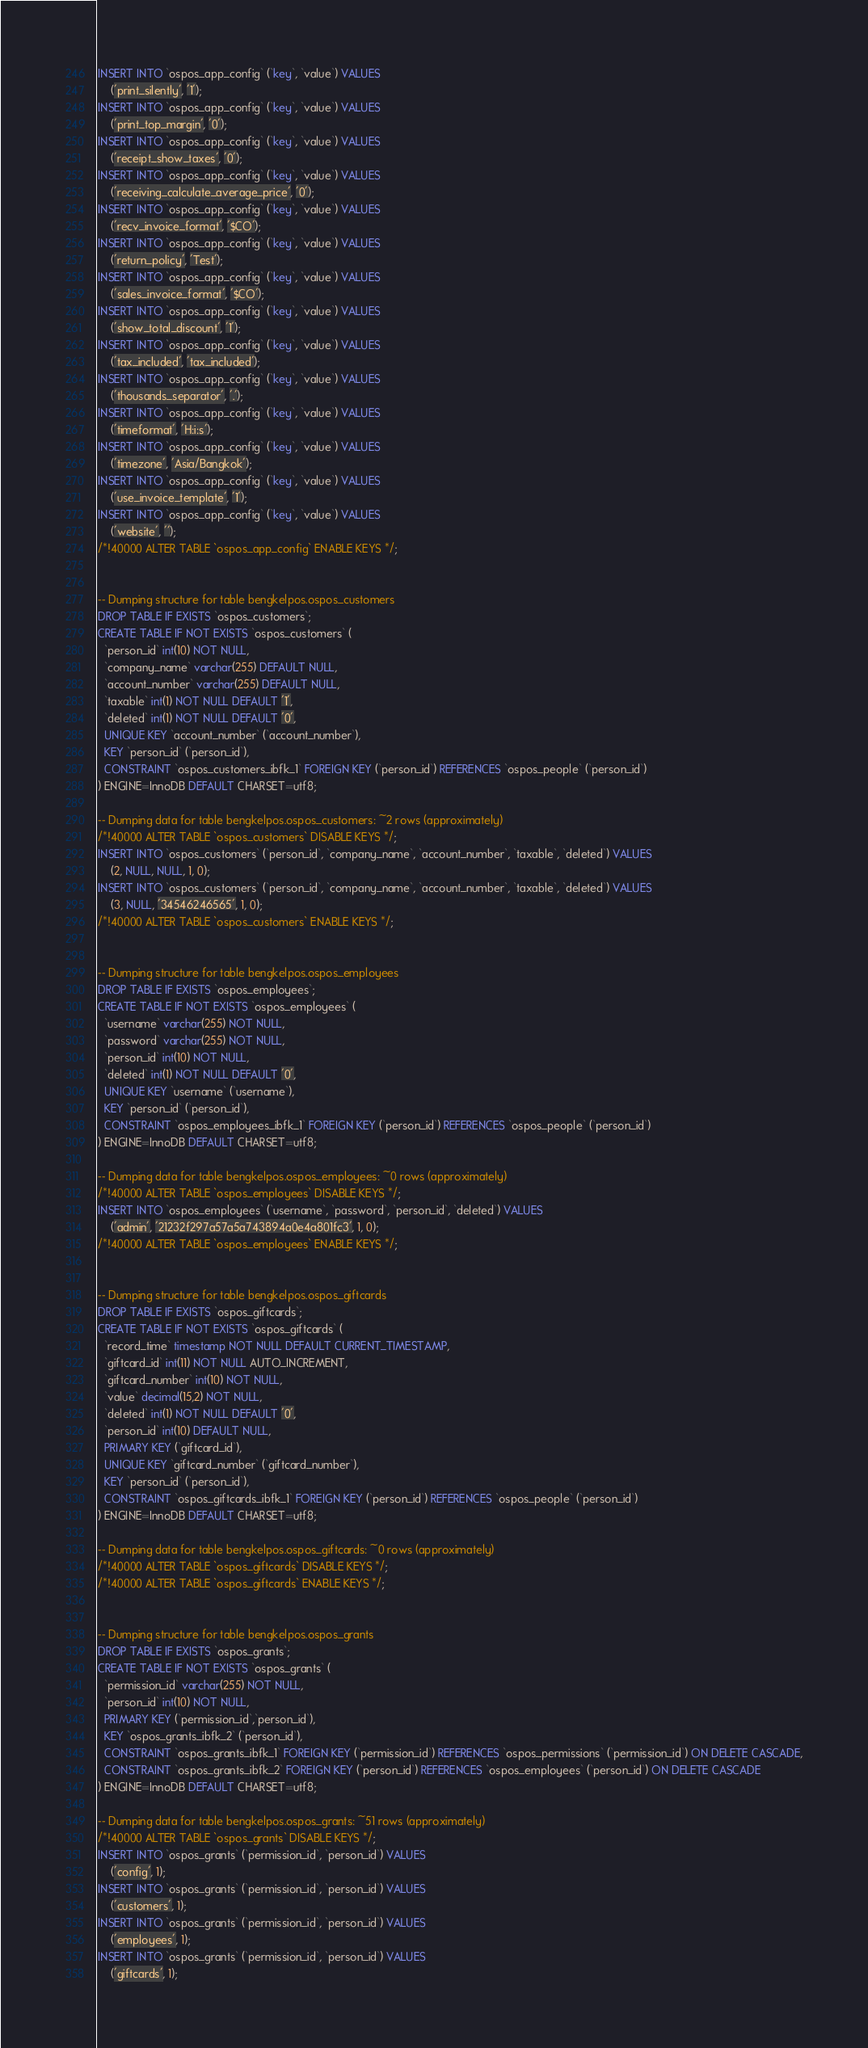Convert code to text. <code><loc_0><loc_0><loc_500><loc_500><_SQL_>INSERT INTO `ospos_app_config` (`key`, `value`) VALUES
	('print_silently', '1');
INSERT INTO `ospos_app_config` (`key`, `value`) VALUES
	('print_top_margin', '0');
INSERT INTO `ospos_app_config` (`key`, `value`) VALUES
	('receipt_show_taxes', '0');
INSERT INTO `ospos_app_config` (`key`, `value`) VALUES
	('receiving_calculate_average_price', '0');
INSERT INTO `ospos_app_config` (`key`, `value`) VALUES
	('recv_invoice_format', '$CO');
INSERT INTO `ospos_app_config` (`key`, `value`) VALUES
	('return_policy', 'Test');
INSERT INTO `ospos_app_config` (`key`, `value`) VALUES
	('sales_invoice_format', '$CO');
INSERT INTO `ospos_app_config` (`key`, `value`) VALUES
	('show_total_discount', '1');
INSERT INTO `ospos_app_config` (`key`, `value`) VALUES
	('tax_included', 'tax_included');
INSERT INTO `ospos_app_config` (`key`, `value`) VALUES
	('thousands_separator', '.');
INSERT INTO `ospos_app_config` (`key`, `value`) VALUES
	('timeformat', 'H:i:s');
INSERT INTO `ospos_app_config` (`key`, `value`) VALUES
	('timezone', 'Asia/Bangkok');
INSERT INTO `ospos_app_config` (`key`, `value`) VALUES
	('use_invoice_template', '1');
INSERT INTO `ospos_app_config` (`key`, `value`) VALUES
	('website', '');
/*!40000 ALTER TABLE `ospos_app_config` ENABLE KEYS */;


-- Dumping structure for table bengkelpos.ospos_customers
DROP TABLE IF EXISTS `ospos_customers`;
CREATE TABLE IF NOT EXISTS `ospos_customers` (
  `person_id` int(10) NOT NULL,
  `company_name` varchar(255) DEFAULT NULL,
  `account_number` varchar(255) DEFAULT NULL,
  `taxable` int(1) NOT NULL DEFAULT '1',
  `deleted` int(1) NOT NULL DEFAULT '0',
  UNIQUE KEY `account_number` (`account_number`),
  KEY `person_id` (`person_id`),
  CONSTRAINT `ospos_customers_ibfk_1` FOREIGN KEY (`person_id`) REFERENCES `ospos_people` (`person_id`)
) ENGINE=InnoDB DEFAULT CHARSET=utf8;

-- Dumping data for table bengkelpos.ospos_customers: ~2 rows (approximately)
/*!40000 ALTER TABLE `ospos_customers` DISABLE KEYS */;
INSERT INTO `ospos_customers` (`person_id`, `company_name`, `account_number`, `taxable`, `deleted`) VALUES
	(2, NULL, NULL, 1, 0);
INSERT INTO `ospos_customers` (`person_id`, `company_name`, `account_number`, `taxable`, `deleted`) VALUES
	(3, NULL, '34546246565', 1, 0);
/*!40000 ALTER TABLE `ospos_customers` ENABLE KEYS */;


-- Dumping structure for table bengkelpos.ospos_employees
DROP TABLE IF EXISTS `ospos_employees`;
CREATE TABLE IF NOT EXISTS `ospos_employees` (
  `username` varchar(255) NOT NULL,
  `password` varchar(255) NOT NULL,
  `person_id` int(10) NOT NULL,
  `deleted` int(1) NOT NULL DEFAULT '0',
  UNIQUE KEY `username` (`username`),
  KEY `person_id` (`person_id`),
  CONSTRAINT `ospos_employees_ibfk_1` FOREIGN KEY (`person_id`) REFERENCES `ospos_people` (`person_id`)
) ENGINE=InnoDB DEFAULT CHARSET=utf8;

-- Dumping data for table bengkelpos.ospos_employees: ~0 rows (approximately)
/*!40000 ALTER TABLE `ospos_employees` DISABLE KEYS */;
INSERT INTO `ospos_employees` (`username`, `password`, `person_id`, `deleted`) VALUES
	('admin', '21232f297a57a5a743894a0e4a801fc3', 1, 0);
/*!40000 ALTER TABLE `ospos_employees` ENABLE KEYS */;


-- Dumping structure for table bengkelpos.ospos_giftcards
DROP TABLE IF EXISTS `ospos_giftcards`;
CREATE TABLE IF NOT EXISTS `ospos_giftcards` (
  `record_time` timestamp NOT NULL DEFAULT CURRENT_TIMESTAMP,
  `giftcard_id` int(11) NOT NULL AUTO_INCREMENT,
  `giftcard_number` int(10) NOT NULL,
  `value` decimal(15,2) NOT NULL,
  `deleted` int(1) NOT NULL DEFAULT '0',
  `person_id` int(10) DEFAULT NULL,
  PRIMARY KEY (`giftcard_id`),
  UNIQUE KEY `giftcard_number` (`giftcard_number`),
  KEY `person_id` (`person_id`),
  CONSTRAINT `ospos_giftcards_ibfk_1` FOREIGN KEY (`person_id`) REFERENCES `ospos_people` (`person_id`)
) ENGINE=InnoDB DEFAULT CHARSET=utf8;

-- Dumping data for table bengkelpos.ospos_giftcards: ~0 rows (approximately)
/*!40000 ALTER TABLE `ospos_giftcards` DISABLE KEYS */;
/*!40000 ALTER TABLE `ospos_giftcards` ENABLE KEYS */;


-- Dumping structure for table bengkelpos.ospos_grants
DROP TABLE IF EXISTS `ospos_grants`;
CREATE TABLE IF NOT EXISTS `ospos_grants` (
  `permission_id` varchar(255) NOT NULL,
  `person_id` int(10) NOT NULL,
  PRIMARY KEY (`permission_id`,`person_id`),
  KEY `ospos_grants_ibfk_2` (`person_id`),
  CONSTRAINT `ospos_grants_ibfk_1` FOREIGN KEY (`permission_id`) REFERENCES `ospos_permissions` (`permission_id`) ON DELETE CASCADE,
  CONSTRAINT `ospos_grants_ibfk_2` FOREIGN KEY (`person_id`) REFERENCES `ospos_employees` (`person_id`) ON DELETE CASCADE
) ENGINE=InnoDB DEFAULT CHARSET=utf8;

-- Dumping data for table bengkelpos.ospos_grants: ~51 rows (approximately)
/*!40000 ALTER TABLE `ospos_grants` DISABLE KEYS */;
INSERT INTO `ospos_grants` (`permission_id`, `person_id`) VALUES
	('config', 1);
INSERT INTO `ospos_grants` (`permission_id`, `person_id`) VALUES
	('customers', 1);
INSERT INTO `ospos_grants` (`permission_id`, `person_id`) VALUES
	('employees', 1);
INSERT INTO `ospos_grants` (`permission_id`, `person_id`) VALUES
	('giftcards', 1);</code> 